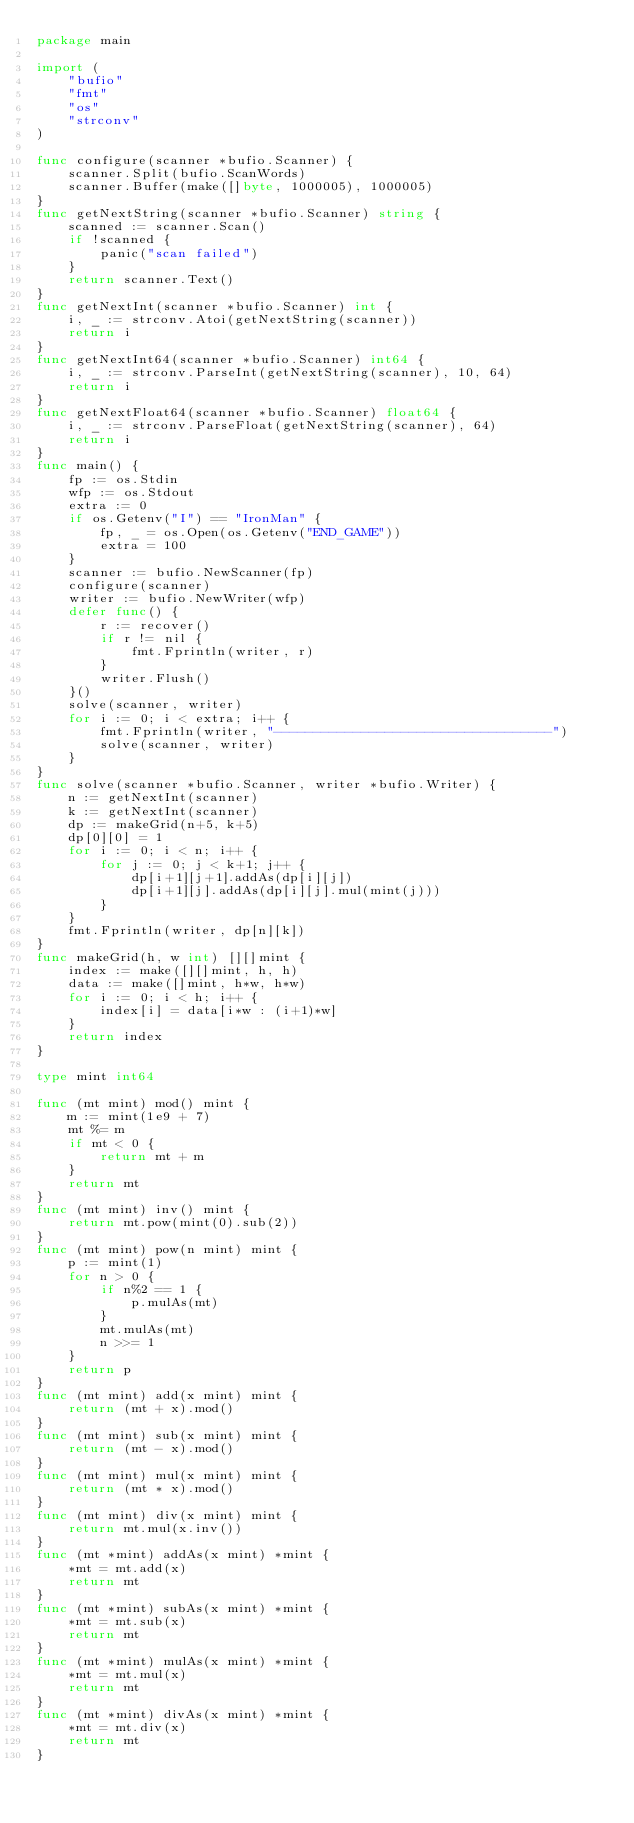Convert code to text. <code><loc_0><loc_0><loc_500><loc_500><_Go_>package main

import (
	"bufio"
	"fmt"
	"os"
	"strconv"
)

func configure(scanner *bufio.Scanner) {
	scanner.Split(bufio.ScanWords)
	scanner.Buffer(make([]byte, 1000005), 1000005)
}
func getNextString(scanner *bufio.Scanner) string {
	scanned := scanner.Scan()
	if !scanned {
		panic("scan failed")
	}
	return scanner.Text()
}
func getNextInt(scanner *bufio.Scanner) int {
	i, _ := strconv.Atoi(getNextString(scanner))
	return i
}
func getNextInt64(scanner *bufio.Scanner) int64 {
	i, _ := strconv.ParseInt(getNextString(scanner), 10, 64)
	return i
}
func getNextFloat64(scanner *bufio.Scanner) float64 {
	i, _ := strconv.ParseFloat(getNextString(scanner), 64)
	return i
}
func main() {
	fp := os.Stdin
	wfp := os.Stdout
	extra := 0
	if os.Getenv("I") == "IronMan" {
		fp, _ = os.Open(os.Getenv("END_GAME"))
		extra = 100
	}
	scanner := bufio.NewScanner(fp)
	configure(scanner)
	writer := bufio.NewWriter(wfp)
	defer func() {
		r := recover()
		if r != nil {
			fmt.Fprintln(writer, r)
		}
		writer.Flush()
	}()
	solve(scanner, writer)
	for i := 0; i < extra; i++ {
		fmt.Fprintln(writer, "-----------------------------------")
		solve(scanner, writer)
	}
}
func solve(scanner *bufio.Scanner, writer *bufio.Writer) {
	n := getNextInt(scanner)
	k := getNextInt(scanner)
	dp := makeGrid(n+5, k+5)
	dp[0][0] = 1
	for i := 0; i < n; i++ {
		for j := 0; j < k+1; j++ {
			dp[i+1][j+1].addAs(dp[i][j])
			dp[i+1][j].addAs(dp[i][j].mul(mint(j)))
		}
	}
	fmt.Fprintln(writer, dp[n][k])
}
func makeGrid(h, w int) [][]mint {
	index := make([][]mint, h, h)
	data := make([]mint, h*w, h*w)
	for i := 0; i < h; i++ {
		index[i] = data[i*w : (i+1)*w]
	}
	return index
}

type mint int64

func (mt mint) mod() mint {
	m := mint(1e9 + 7)
	mt %= m
	if mt < 0 {
		return mt + m
	}
	return mt
}
func (mt mint) inv() mint {
	return mt.pow(mint(0).sub(2))
}
func (mt mint) pow(n mint) mint {
	p := mint(1)
	for n > 0 {
		if n%2 == 1 {
			p.mulAs(mt)
		}
		mt.mulAs(mt)
		n >>= 1
	}
	return p
}
func (mt mint) add(x mint) mint {
	return (mt + x).mod()
}
func (mt mint) sub(x mint) mint {
	return (mt - x).mod()
}
func (mt mint) mul(x mint) mint {
	return (mt * x).mod()
}
func (mt mint) div(x mint) mint {
	return mt.mul(x.inv())
}
func (mt *mint) addAs(x mint) *mint {
	*mt = mt.add(x)
	return mt
}
func (mt *mint) subAs(x mint) *mint {
	*mt = mt.sub(x)
	return mt
}
func (mt *mint) mulAs(x mint) *mint {
	*mt = mt.mul(x)
	return mt
}
func (mt *mint) divAs(x mint) *mint {
	*mt = mt.div(x)
	return mt
}

</code> 